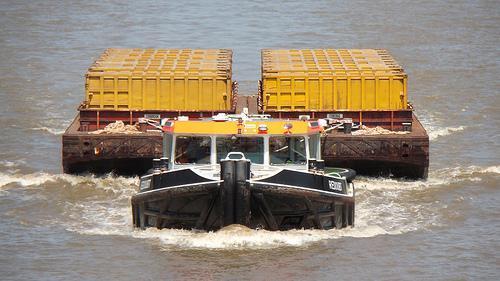How many rows of containers are there?
Give a very brief answer. 2. How many ships are there?
Give a very brief answer. 1. How many barges are there?
Give a very brief answer. 1. How many containers are visible on the boat?
Give a very brief answer. 2. 